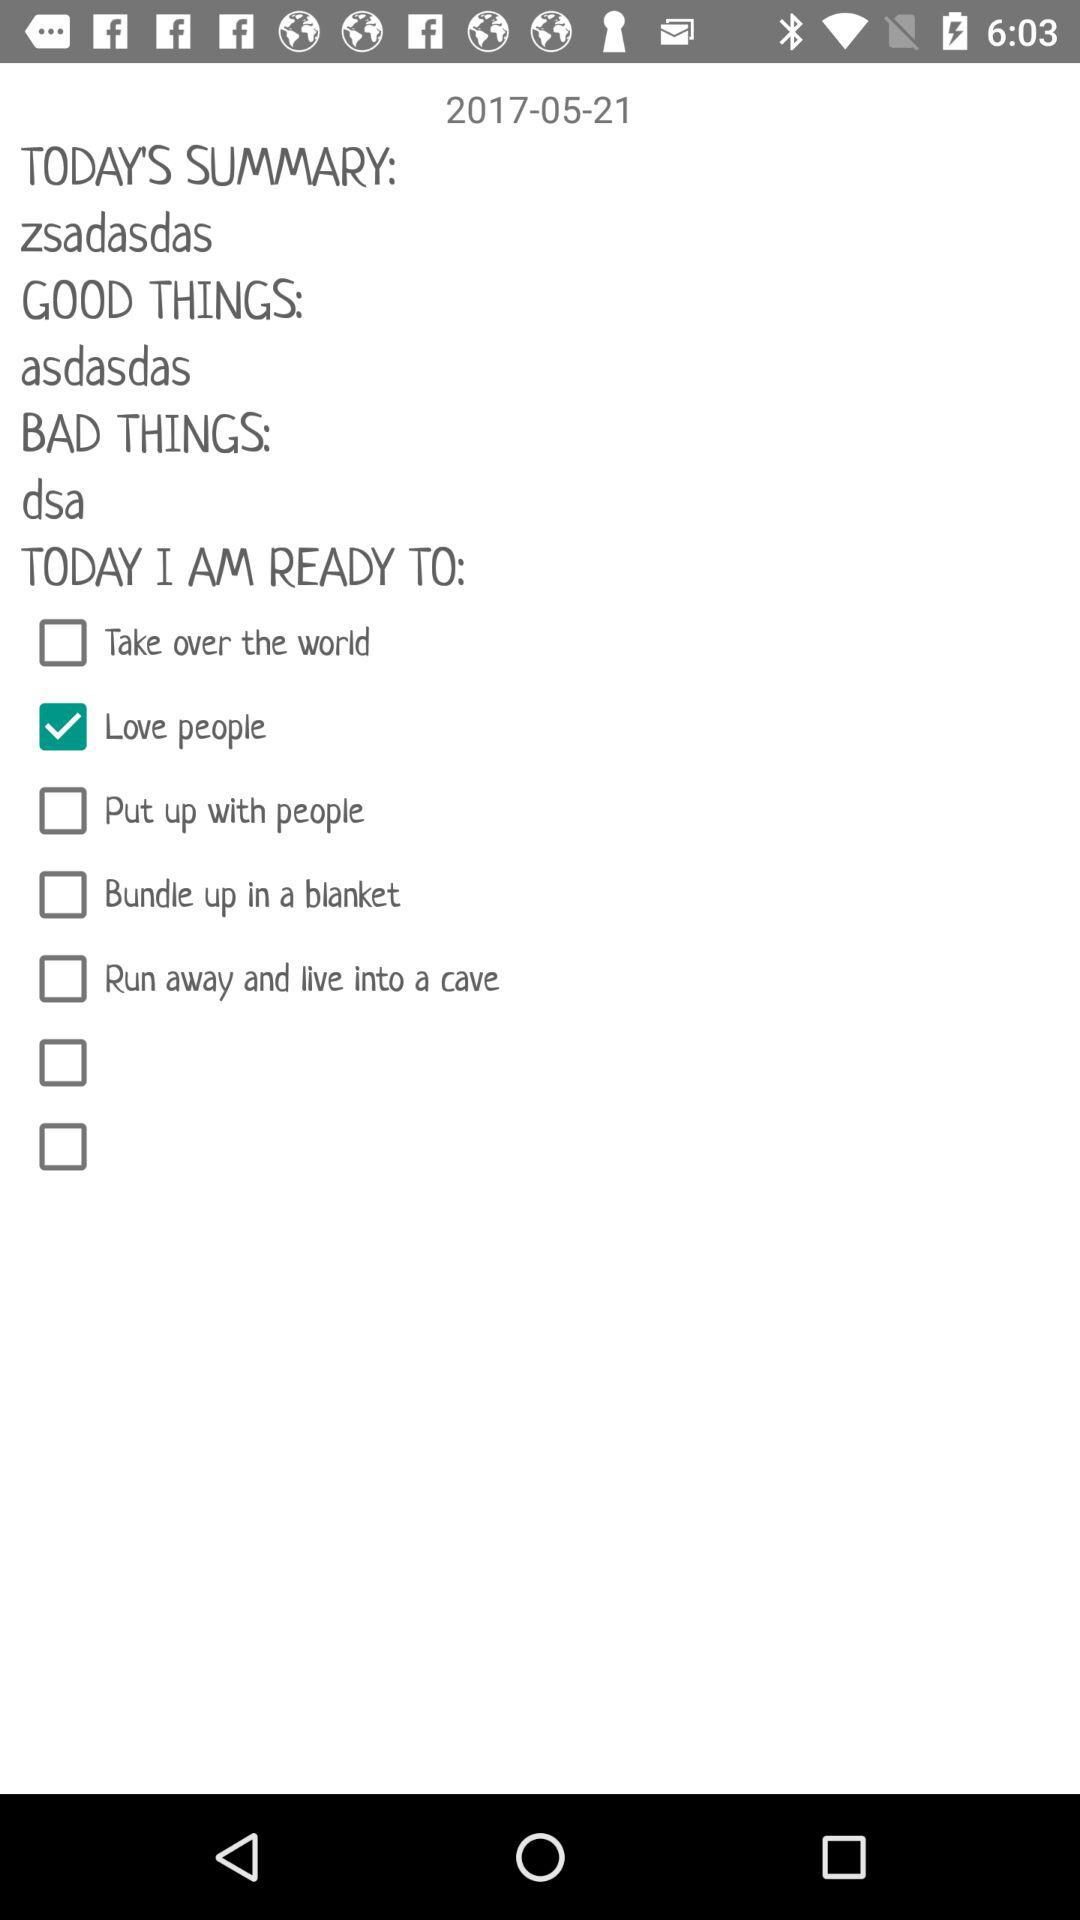What is the selected date? The selected date is May 21, 2017. 